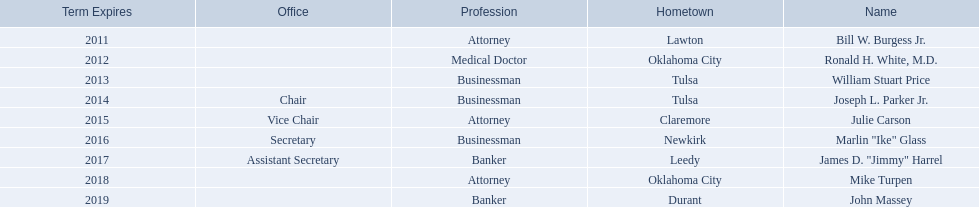Which regents are from tulsa? William Stuart Price, Joseph L. Parker Jr. Could you help me parse every detail presented in this table? {'header': ['Term Expires', 'Office', 'Profession', 'Hometown', 'Name'], 'rows': [['2011', '', 'Attorney', 'Lawton', 'Bill W. Burgess Jr.'], ['2012', '', 'Medical Doctor', 'Oklahoma City', 'Ronald H. White, M.D.'], ['2013', '', 'Businessman', 'Tulsa', 'William Stuart Price'], ['2014', 'Chair', 'Businessman', 'Tulsa', 'Joseph L. Parker Jr.'], ['2015', 'Vice Chair', 'Attorney', 'Claremore', 'Julie Carson'], ['2016', 'Secretary', 'Businessman', 'Newkirk', 'Marlin "Ike" Glass'], ['2017', 'Assistant Secretary', 'Banker', 'Leedy', 'James D. "Jimmy" Harrel'], ['2018', '', 'Attorney', 'Oklahoma City', 'Mike Turpen'], ['2019', '', 'Banker', 'Durant', 'John Massey']]} Which of these is not joseph parker, jr.? William Stuart Price. 